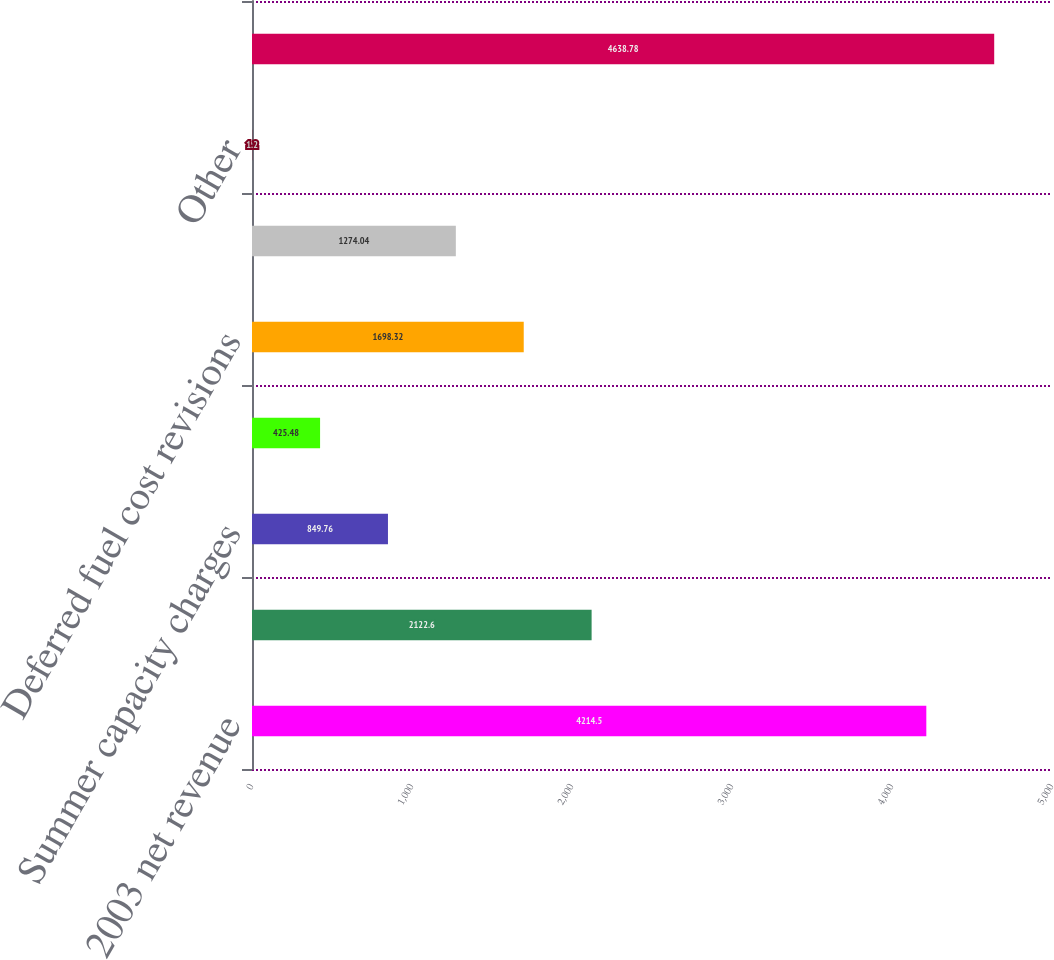Convert chart to OTSL. <chart><loc_0><loc_0><loc_500><loc_500><bar_chart><fcel>2003 net revenue<fcel>Volume/weather<fcel>Summer capacity charges<fcel>Base rates<fcel>Deferred fuel cost revisions<fcel>Price applied to unbilled<fcel>Other<fcel>2004 net revenue<nl><fcel>4214.5<fcel>2122.6<fcel>849.76<fcel>425.48<fcel>1698.32<fcel>1274.04<fcel>1.2<fcel>4638.78<nl></chart> 